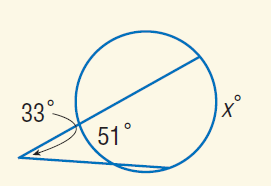Question: Find x.
Choices:
A. 33
B. 51
C. 84
D. 117
Answer with the letter. Answer: D 